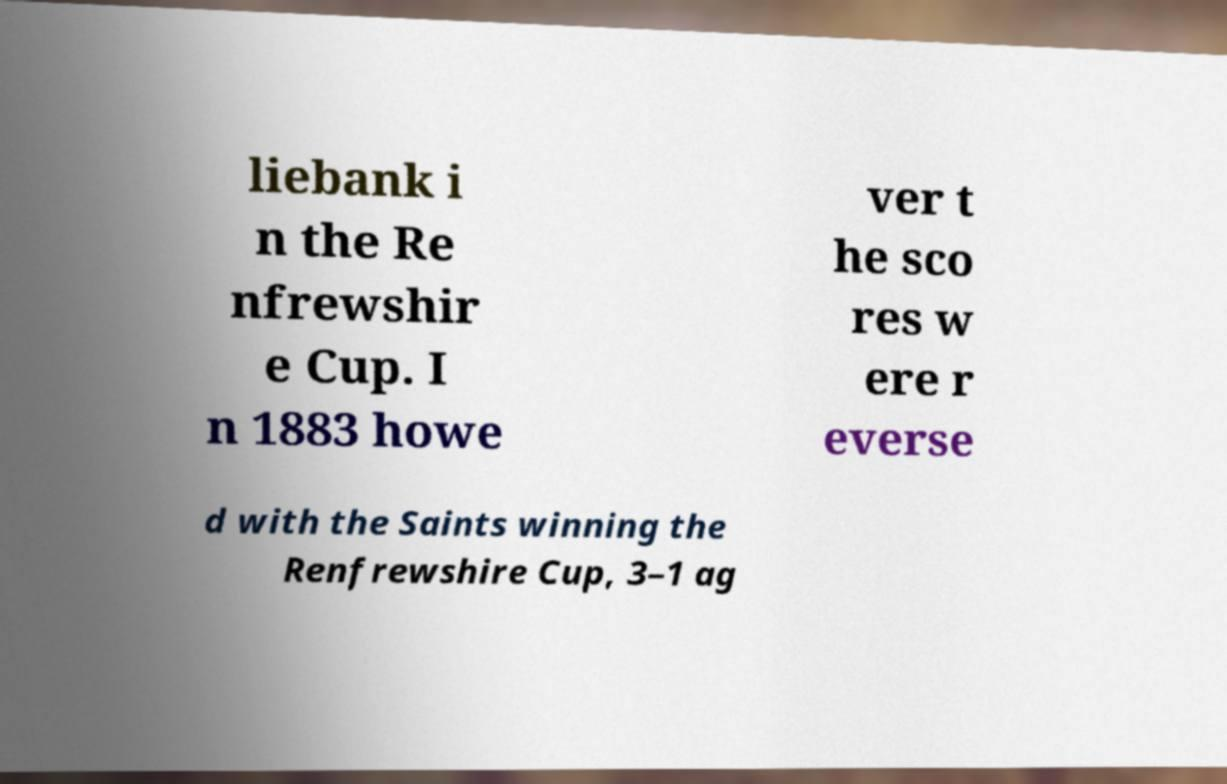Please read and relay the text visible in this image. What does it say? liebank i n the Re nfrewshir e Cup. I n 1883 howe ver t he sco res w ere r everse d with the Saints winning the Renfrewshire Cup, 3–1 ag 